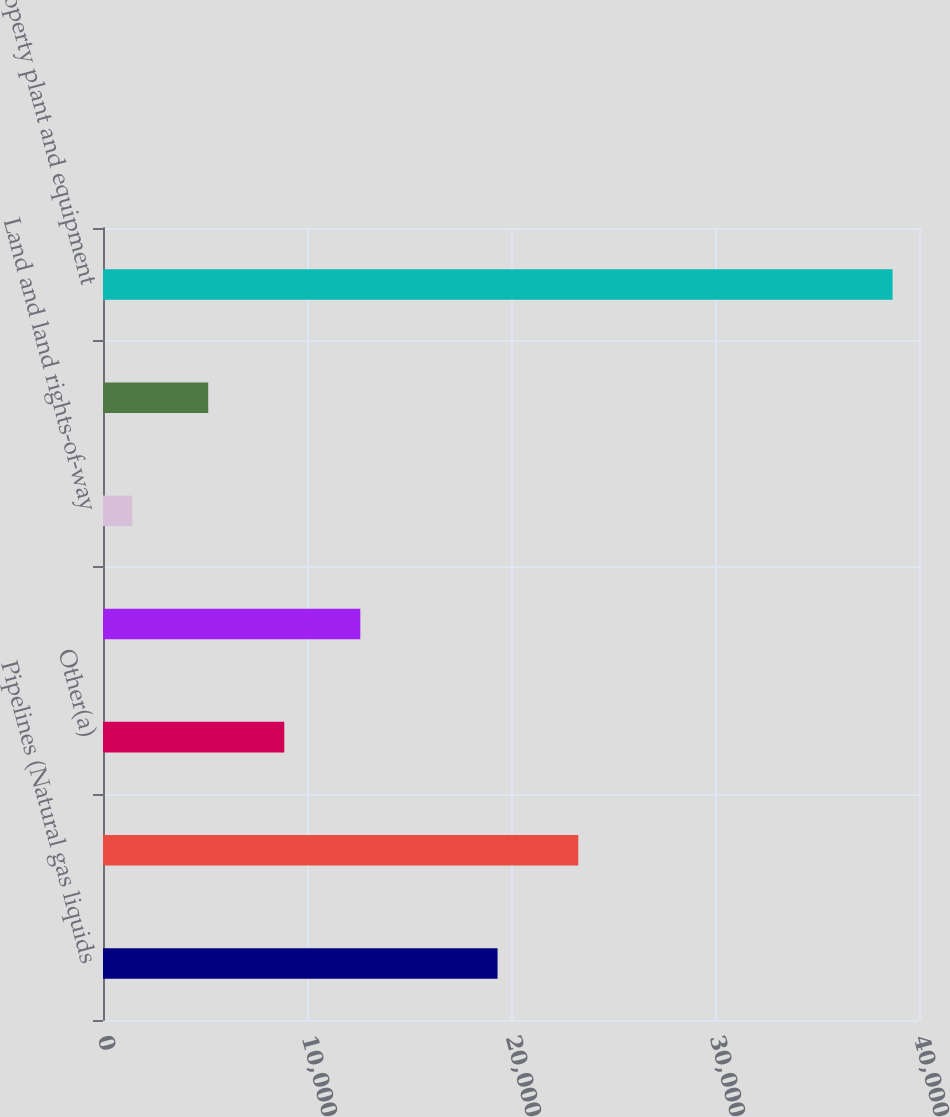Convert chart to OTSL. <chart><loc_0><loc_0><loc_500><loc_500><bar_chart><fcel>Pipelines (Natural gas liquids<fcel>Equipment (Natural gas liquids<fcel>Other(a)<fcel>Accumulated depreciation<fcel>Land and land rights-of-way<fcel>Construction work in process<fcel>Property plant and equipment<nl><fcel>19341<fcel>23298<fcel>8885.8<fcel>12613.2<fcel>1431<fcel>5158.4<fcel>38705<nl></chart> 